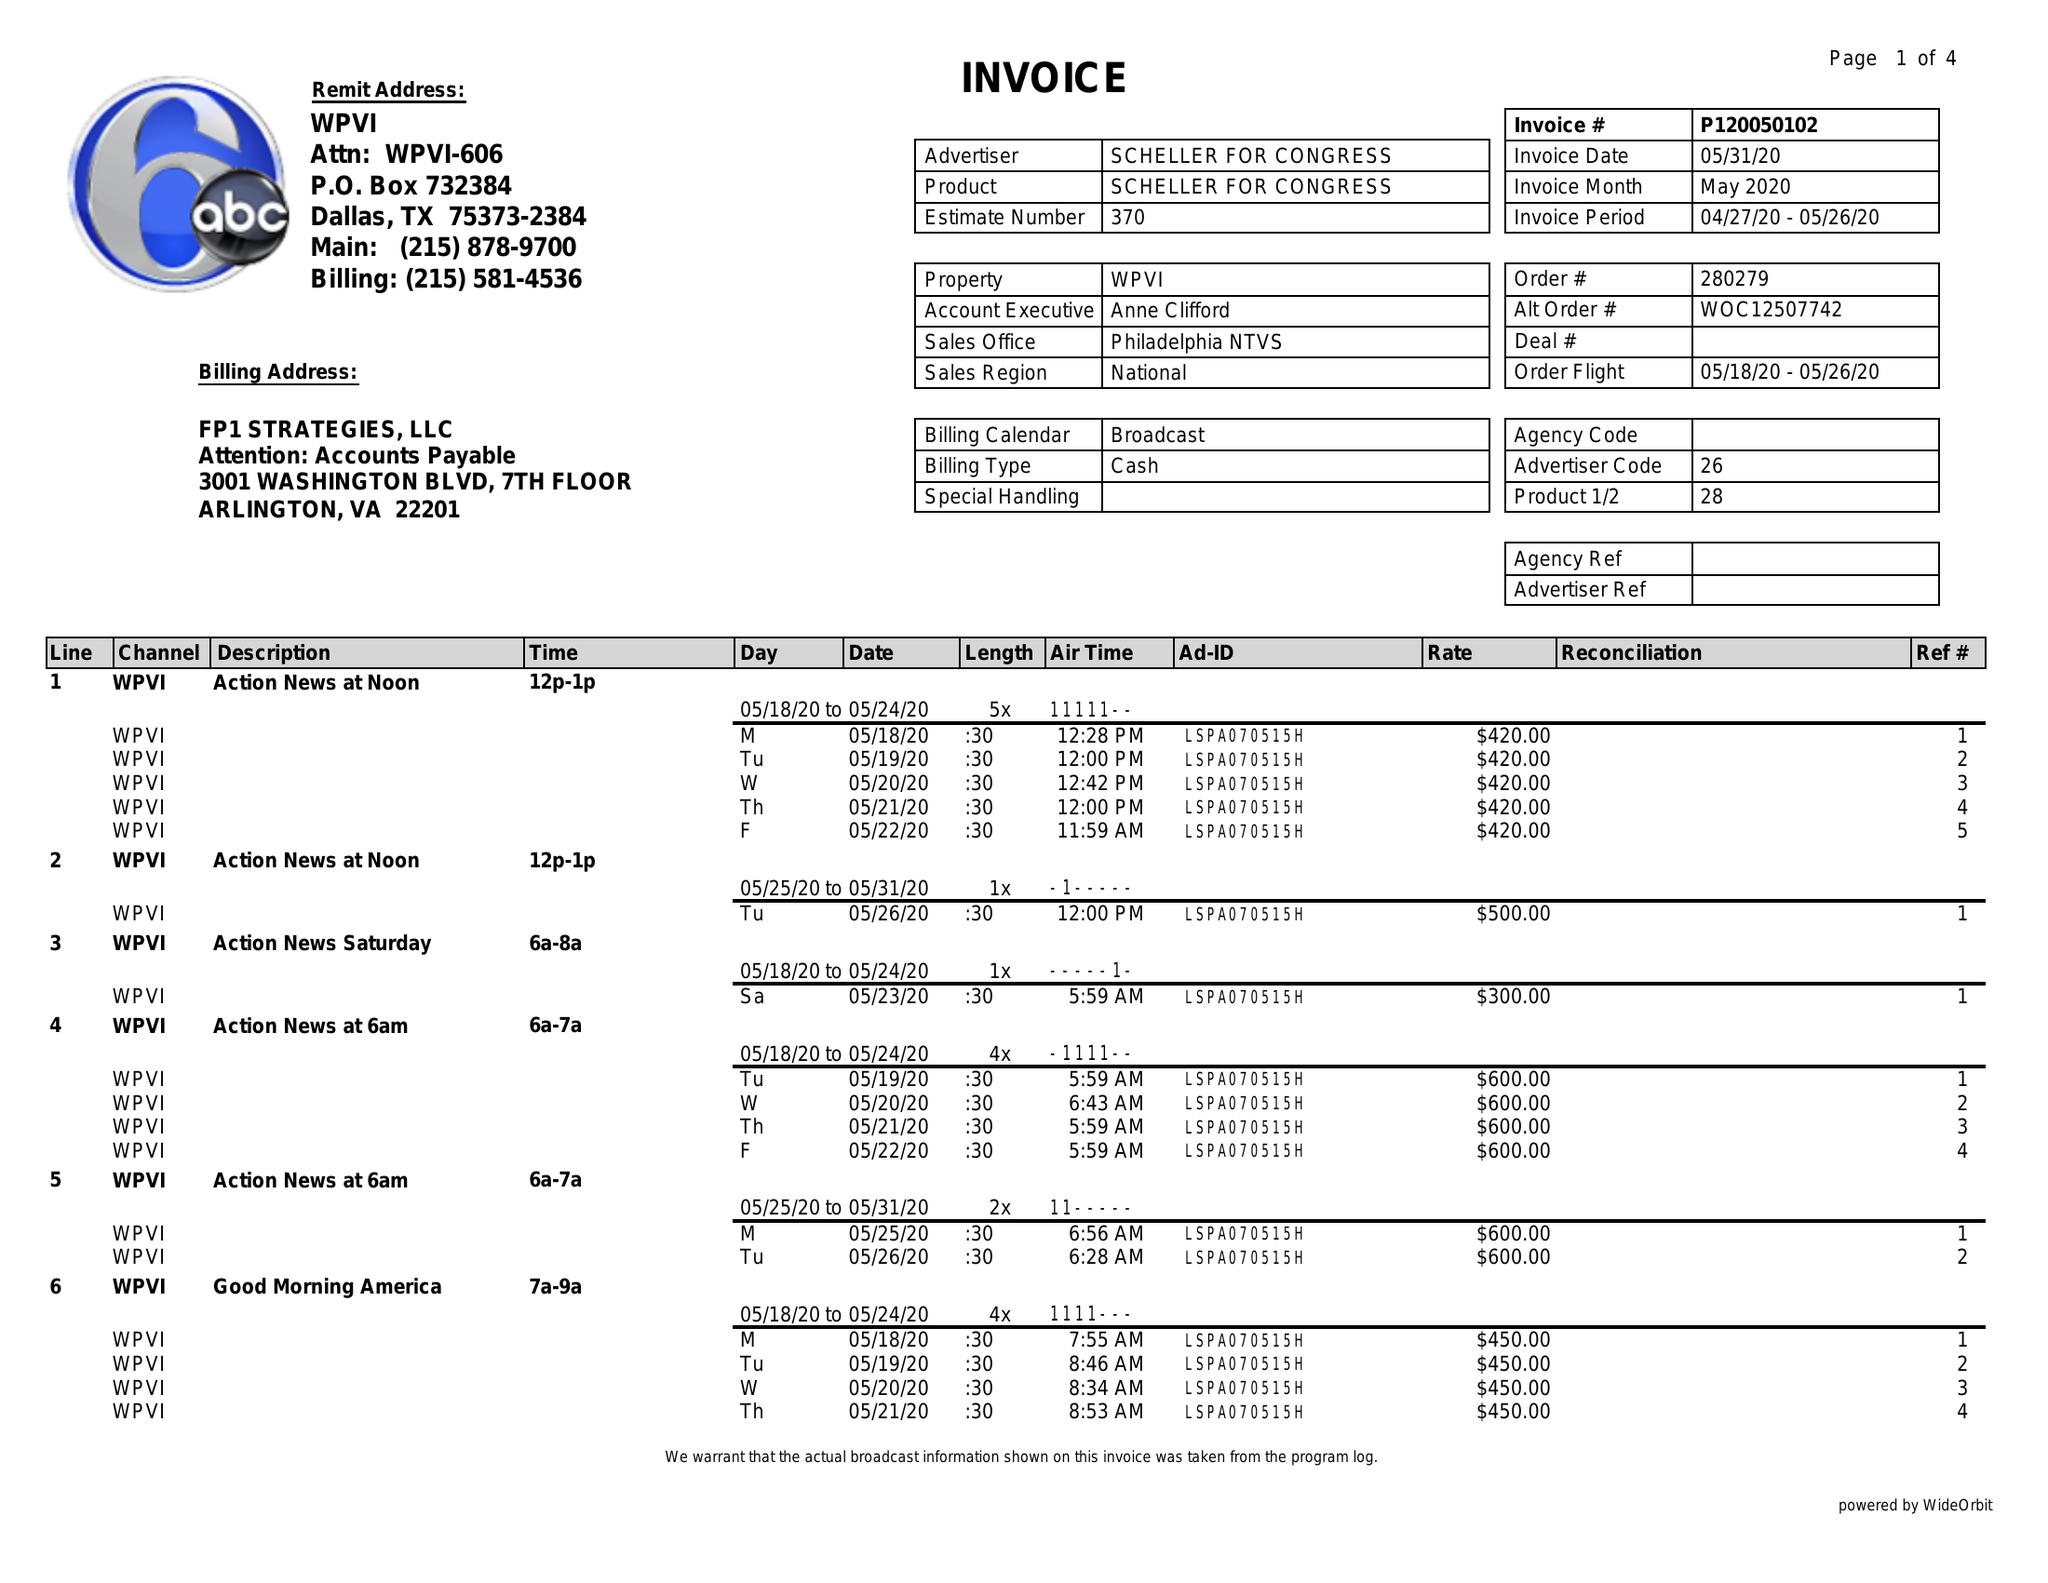What is the value for the contract_num?
Answer the question using a single word or phrase. P120050102 